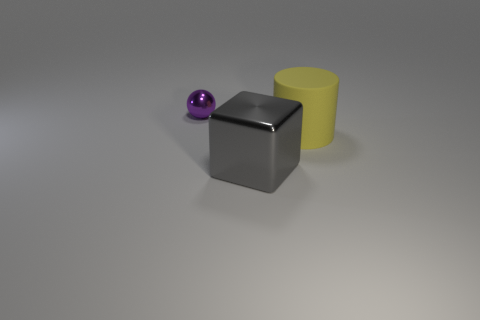Add 2 big red metal balls. How many objects exist? 5 Subtract all cubes. How many objects are left? 2 Subtract 0 green cylinders. How many objects are left? 3 Subtract all big brown metal blocks. Subtract all big yellow cylinders. How many objects are left? 2 Add 2 small purple objects. How many small purple objects are left? 3 Add 3 big gray metallic objects. How many big gray metallic objects exist? 4 